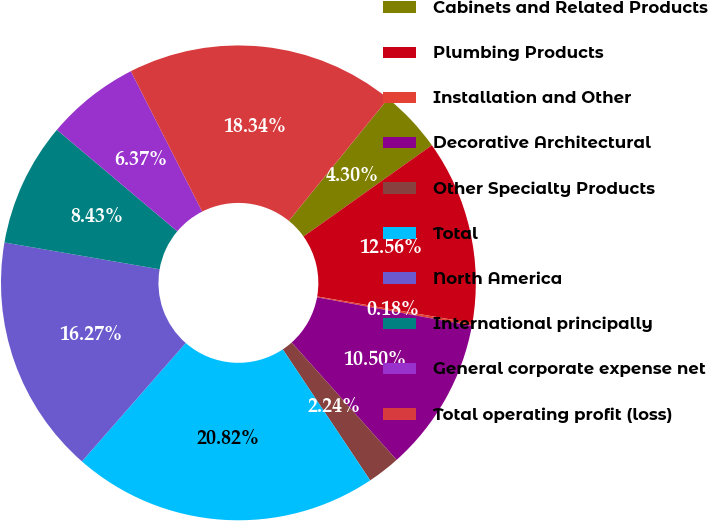<chart> <loc_0><loc_0><loc_500><loc_500><pie_chart><fcel>Cabinets and Related Products<fcel>Plumbing Products<fcel>Installation and Other<fcel>Decorative Architectural<fcel>Other Specialty Products<fcel>Total<fcel>North America<fcel>International principally<fcel>General corporate expense net<fcel>Total operating profit (loss)<nl><fcel>4.3%<fcel>12.56%<fcel>0.18%<fcel>10.5%<fcel>2.24%<fcel>20.82%<fcel>16.27%<fcel>8.43%<fcel>6.37%<fcel>18.34%<nl></chart> 